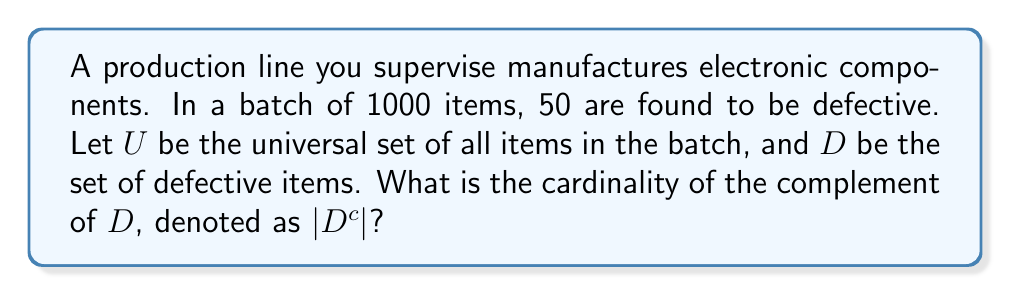Show me your answer to this math problem. To solve this problem, we need to understand the concept of complement sets and how they relate to the given information. Let's break it down step-by-step:

1. Define the sets:
   $U$ = Universal set (all items in the batch)
   $D$ = Set of defective items
   $D^c$ = Complement of $D$ (non-defective items)

2. Given information:
   $|U| = 1000$ (total items in the batch)
   $|D| = 50$ (number of defective items)

3. Relationship between a set and its complement:
   For any set $A$ in a universal set $U$, we have:
   $|U| = |A| + |A^c|$

4. Apply this relationship to our problem:
   $|U| = |D| + |D^c|$
   $1000 = 50 + |D^c|$

5. Solve for $|D^c|$:
   $|D^c| = 1000 - 50 = 950$

Therefore, the cardinality of the complement of $D$, which represents the number of non-defective items, is 950.
Answer: $|D^c| = 950$ 